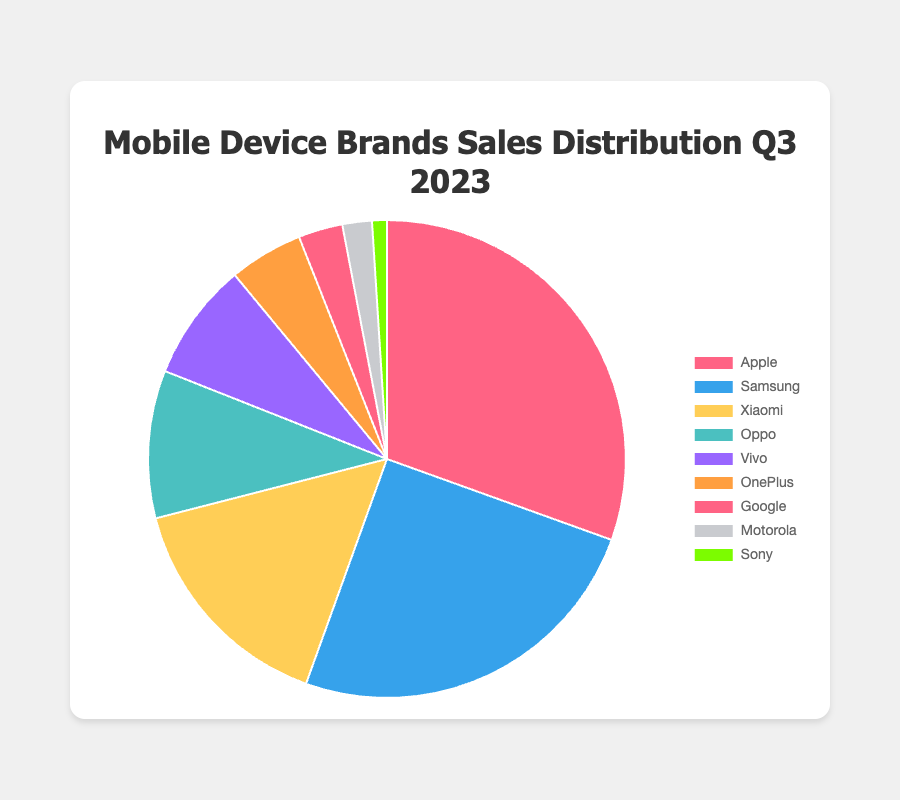Which brand has the highest sales percentage? The sales percentage for each brand is displayed on the pie chart. Apple has the highest sales percentage at 30.5%.
Answer: Apple Which brand has the lowest sales percentage? From the given pie chart, Sony has the lowest sales percentage at 1.0%.
Answer: Sony What is the total combined sales percentage for Xiaomi and Oppo? Xiaomi has a sales percentage of 15.5%, and Oppo has a percentage of 10.0%. Adding these two numbers gives 15.5% + 10.0% = 25.5%.
Answer: 25.5% Compare the sales percentages of Samsung and Google. Which one is greater and by how much? Samsung has a sales percentage of 25.0%, and Google has 3.0%. To find the difference, subtract 3.0% from 25.0%, which is 25.0% - 3.0% = 22.0%. Samsung's sales percentage is greater by 22.0%.
Answer: Samsung by 22.0% Which brand has a difference in sales percentage of more than 20% when compared with Vivo? Vivo has a sales percentage of 8.0%. When compared with Apple at 30.5%, the difference is 30.5% - 8.0% = 22.5%, which is more than 20%.
Answer: Apple How does the sales percentage of OnePlus compare to that of Motorola? OnePlus has a sales percentage of 5.0%, and Motorola has 2.0%. So OnePlus's sales percentage is greater than Motorola's by 5.0% - 2.0% = 3.0%.
Answer: OnePlus by 3.0% What is the difference in sales percentage between the top-performing brand and the second top-performing brand? The top-performing brand is Apple with 30.5%, and the second top-performing brand is Samsung with 25.0%. The difference is 30.5% - 25.0% = 5.5%.
Answer: 5.5% What is the combined sales percentage of the three least performing brands? The three least performing brands are Sony (1.0%), Motorola (2.0%), and Google (3.0%). Adding these gives 1.0% + 2.0% + 3.0% = 6.0%.
Answer: 6.0% Which brand has a sales percentage equal to 5.0% and what color is associated with it on the chart? OnePlus has a sales percentage of 5.0%, and it is represented by an orange color on the chart.
Answer: OnePlus, orange Among the brands listed, how many have a sales percentage less than 10%? The brands with sales percentages less than 10% are Vivo (8.0%), OnePlus (5.0%), Google (3.0%), Motorola (2.0%), and Sony (1.0%). There are 5 brands in this category.
Answer: 5 brands 